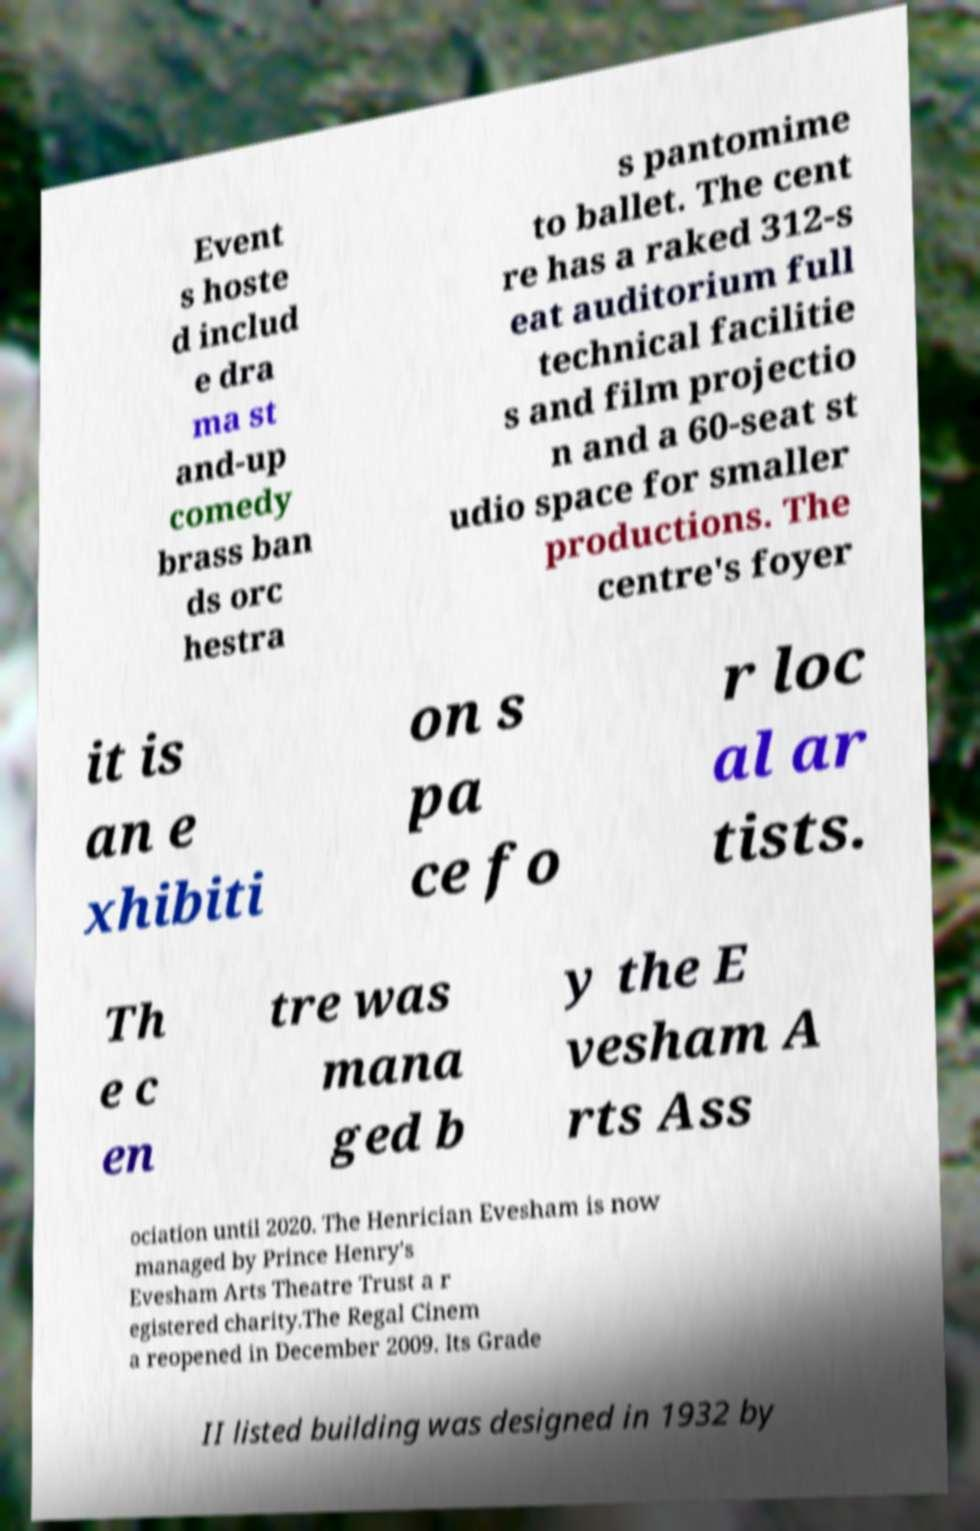There's text embedded in this image that I need extracted. Can you transcribe it verbatim? Event s hoste d includ e dra ma st and-up comedy brass ban ds orc hestra s pantomime to ballet. The cent re has a raked 312-s eat auditorium full technical facilitie s and film projectio n and a 60-seat st udio space for smaller productions. The centre's foyer it is an e xhibiti on s pa ce fo r loc al ar tists. Th e c en tre was mana ged b y the E vesham A rts Ass ociation until 2020. The Henrician Evesham is now managed by Prince Henry's Evesham Arts Theatre Trust a r egistered charity.The Regal Cinem a reopened in December 2009. Its Grade II listed building was designed in 1932 by 